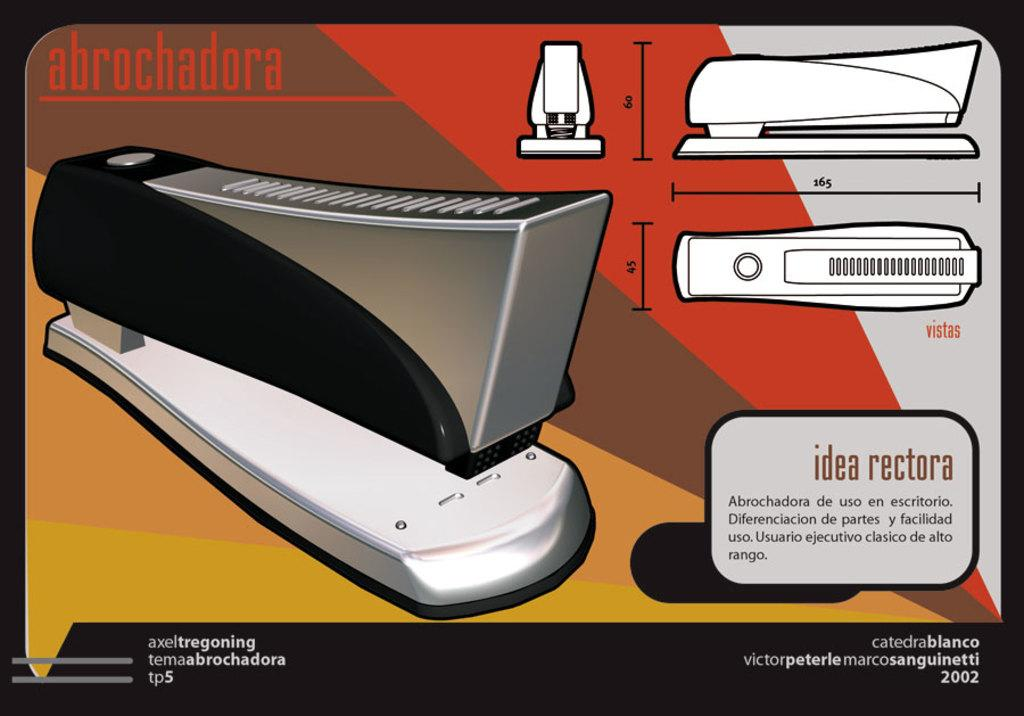Provide a one-sentence caption for the provided image. Picture showing a staple and the name abrochadora as well as the different angles. 